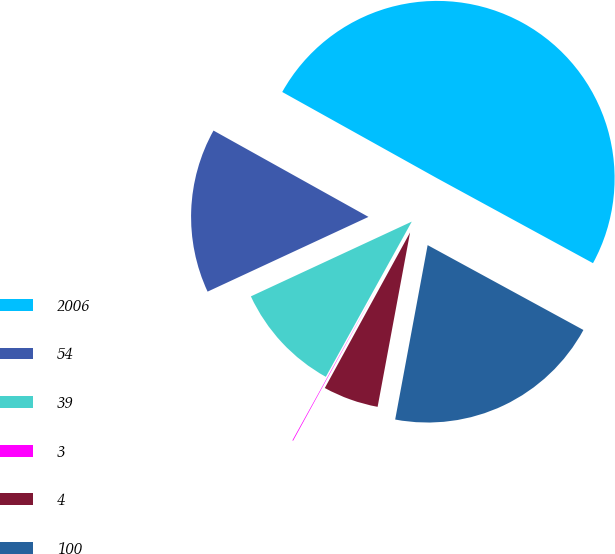Convert chart to OTSL. <chart><loc_0><loc_0><loc_500><loc_500><pie_chart><fcel>2006<fcel>54<fcel>39<fcel>3<fcel>4<fcel>100<nl><fcel>49.85%<fcel>15.01%<fcel>10.03%<fcel>0.07%<fcel>5.05%<fcel>19.99%<nl></chart> 